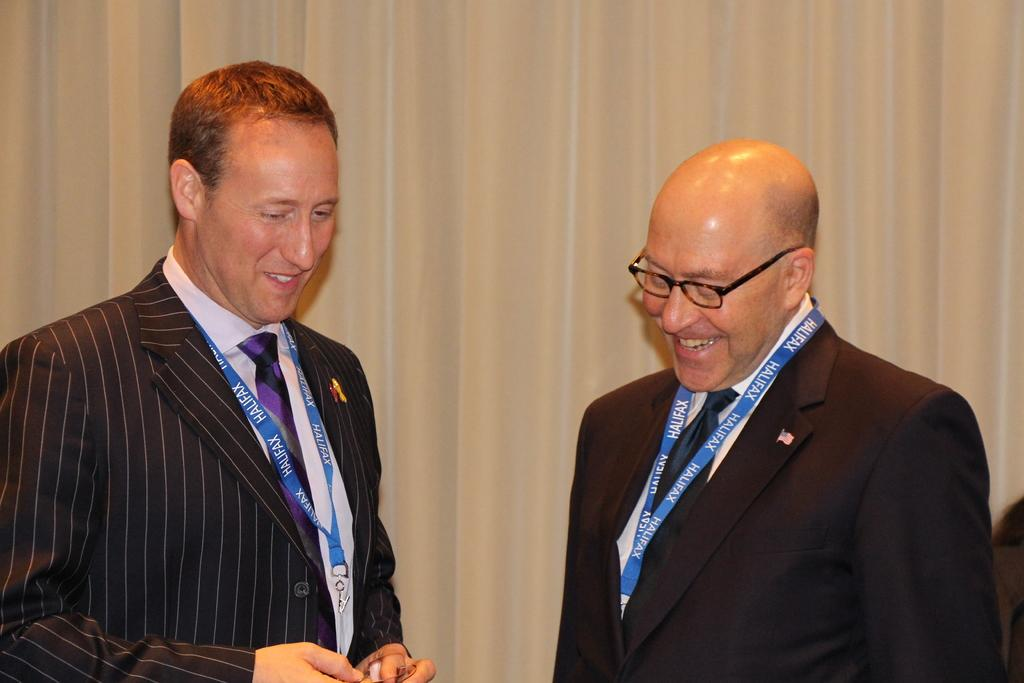How many people are in the image? There are two persons in the image. What are the two persons doing in the image? The two persons are standing and smiling. What can be seen in the background of the image? There is a curtain in the background of the image. What type of cast is visible on the arm of one of the persons in the image? There is no cast visible on any person's arm in the image. What type of slave is depicted in the image? There is no depiction of a slave in the image; it features two smiling persons standing. 